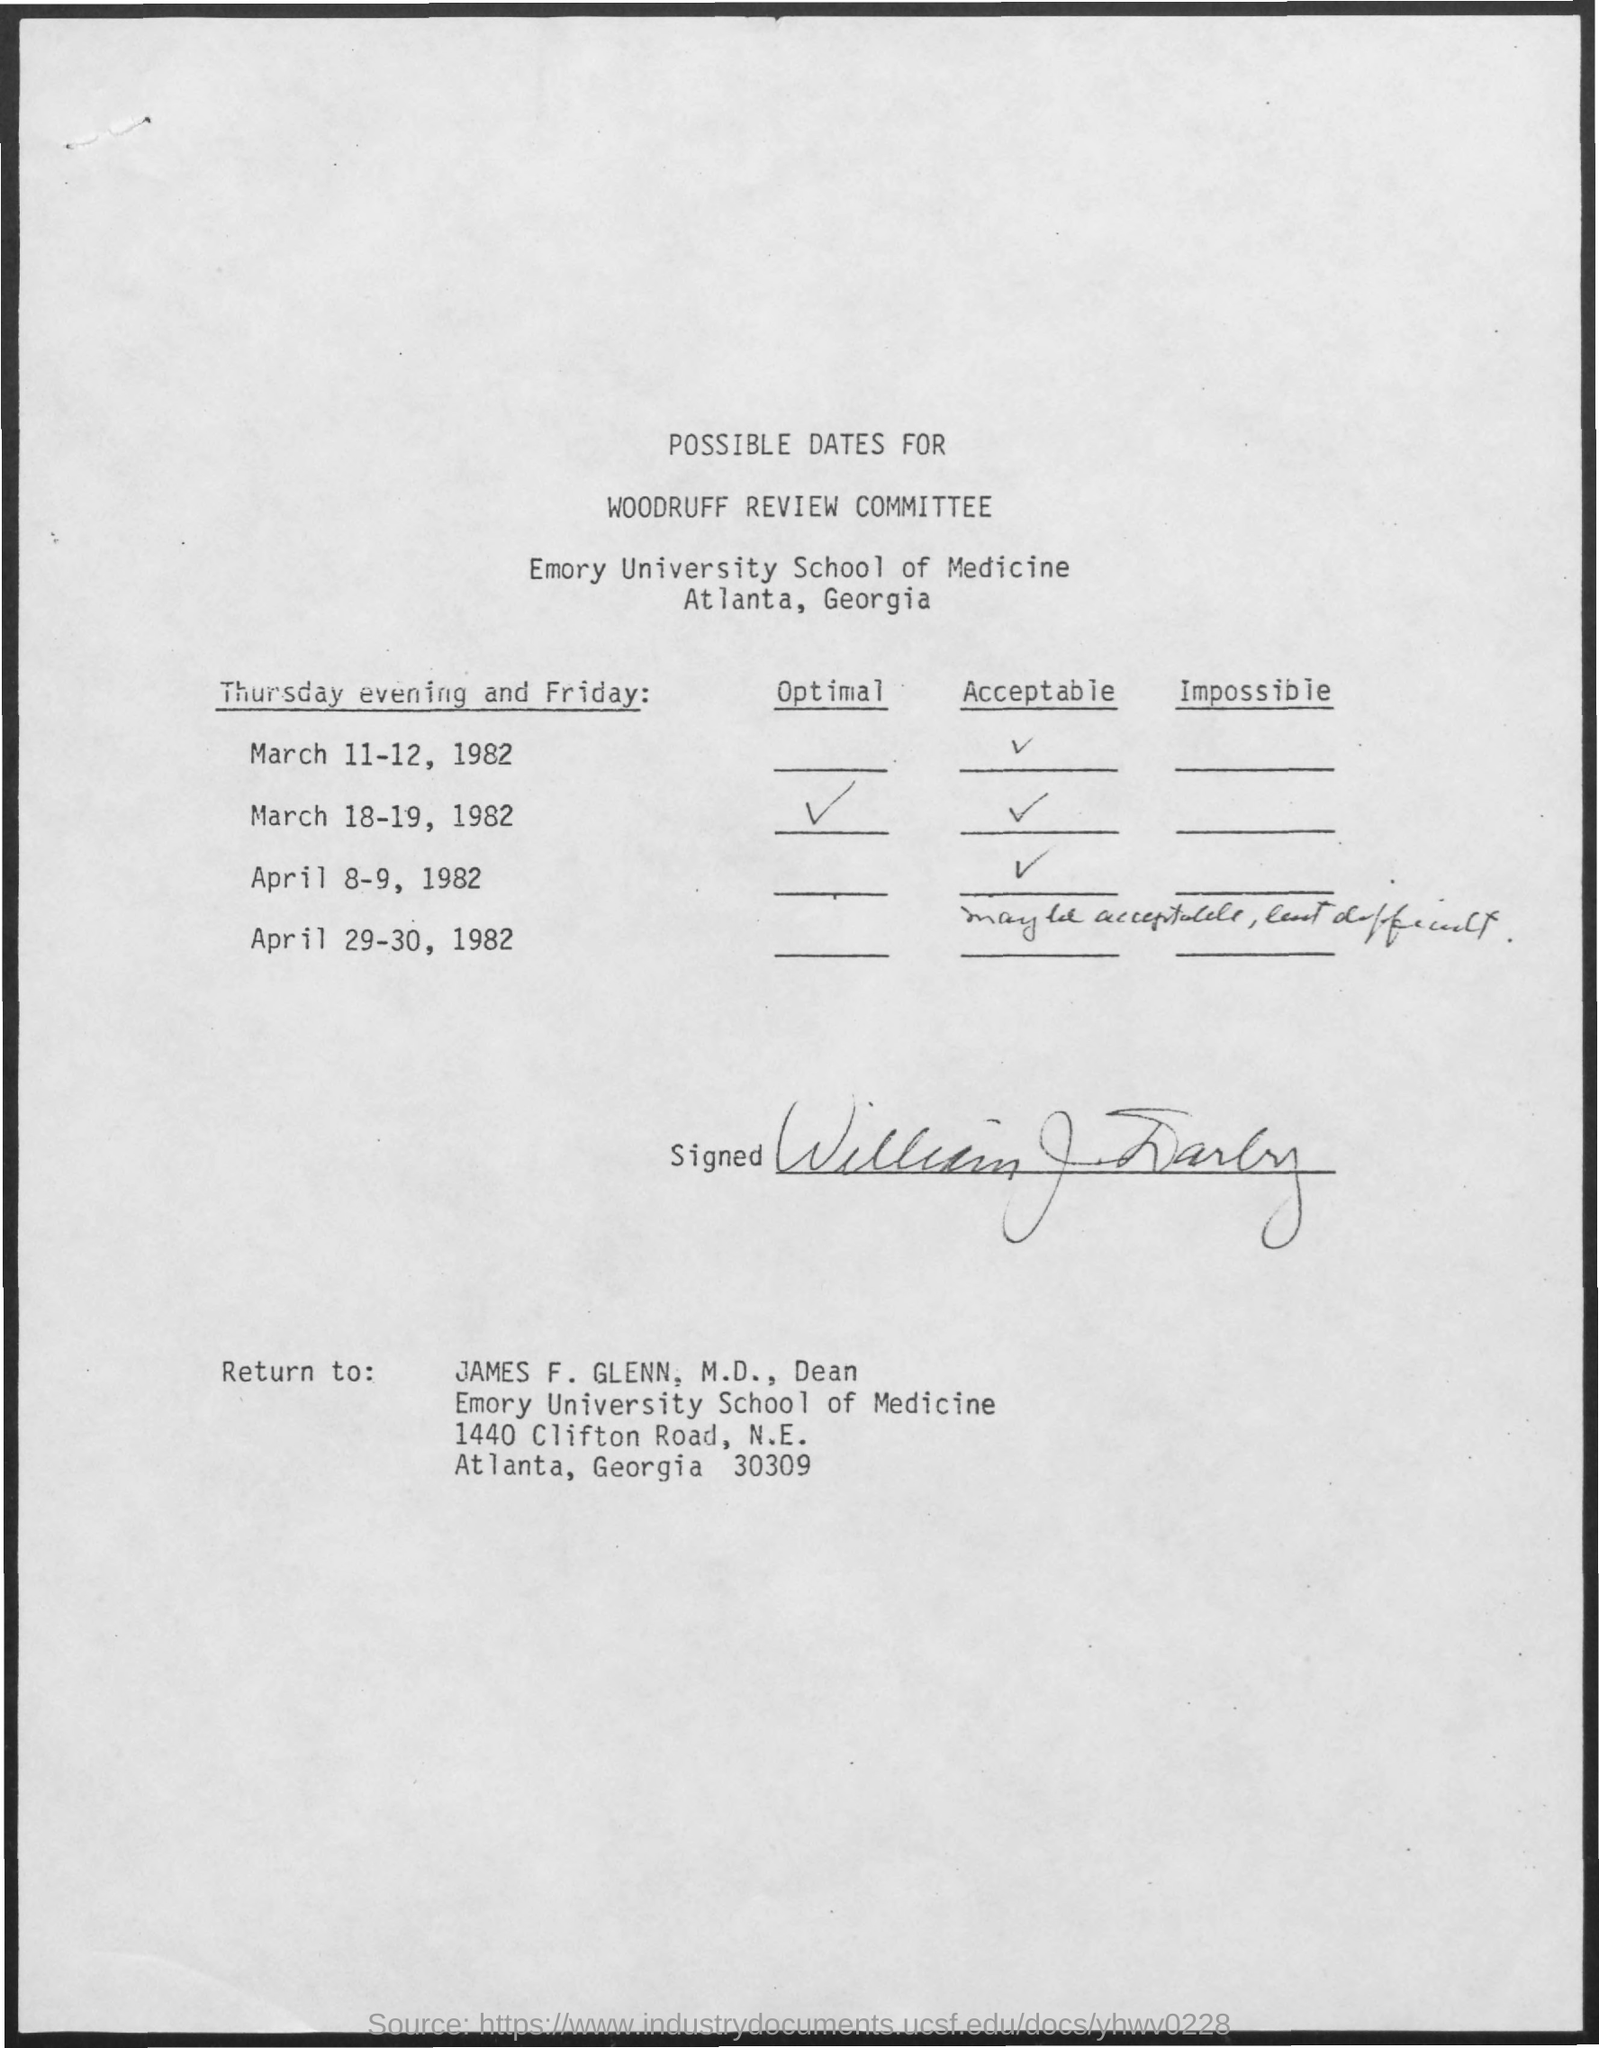What is the document about?
Your answer should be compact. Possible Dates for Woodruff Review Committee. Which university is mentioned?
Make the answer very short. Emory University School of Medicine. Which date is optimal?
Ensure brevity in your answer.  March 18-19, 1982. To whom should the form be returned?
Ensure brevity in your answer.  James F. Glenn. 